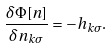<formula> <loc_0><loc_0><loc_500><loc_500>\frac { \delta \Phi [ n ] } { \delta n _ { { k } \sigma } } = - h _ { { k } \sigma } .</formula> 